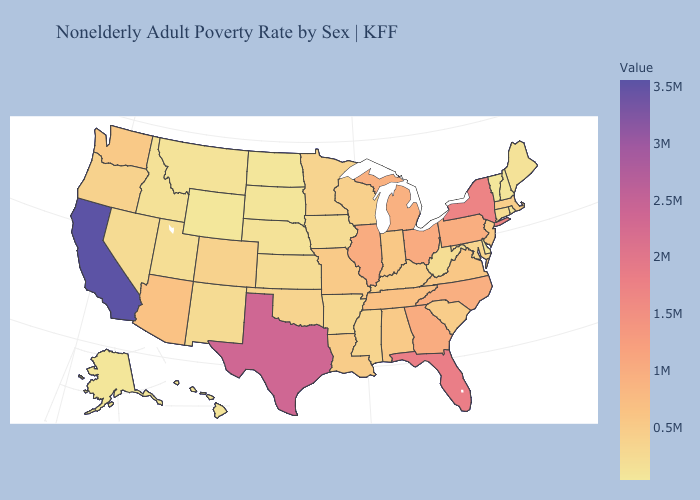Does Wisconsin have a higher value than Texas?
Answer briefly. No. Does Vermont have the lowest value in the USA?
Write a very short answer. Yes. Does Maine have the lowest value in the Northeast?
Quick response, please. No. Does New Hampshire have a lower value than Washington?
Give a very brief answer. Yes. Does Vermont have the lowest value in the USA?
Answer briefly. Yes. Among the states that border Wyoming , does Colorado have the highest value?
Quick response, please. Yes. 